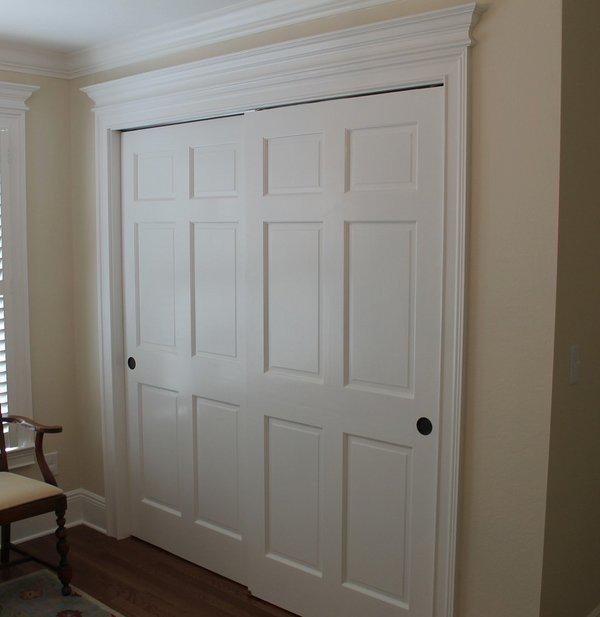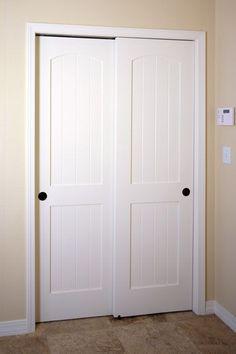The first image is the image on the left, the second image is the image on the right. Analyze the images presented: Is the assertion "In one image, a tan wood three-panel door has square inlays at the top and two long rectangles at the bottom." valid? Answer yes or no. No. 